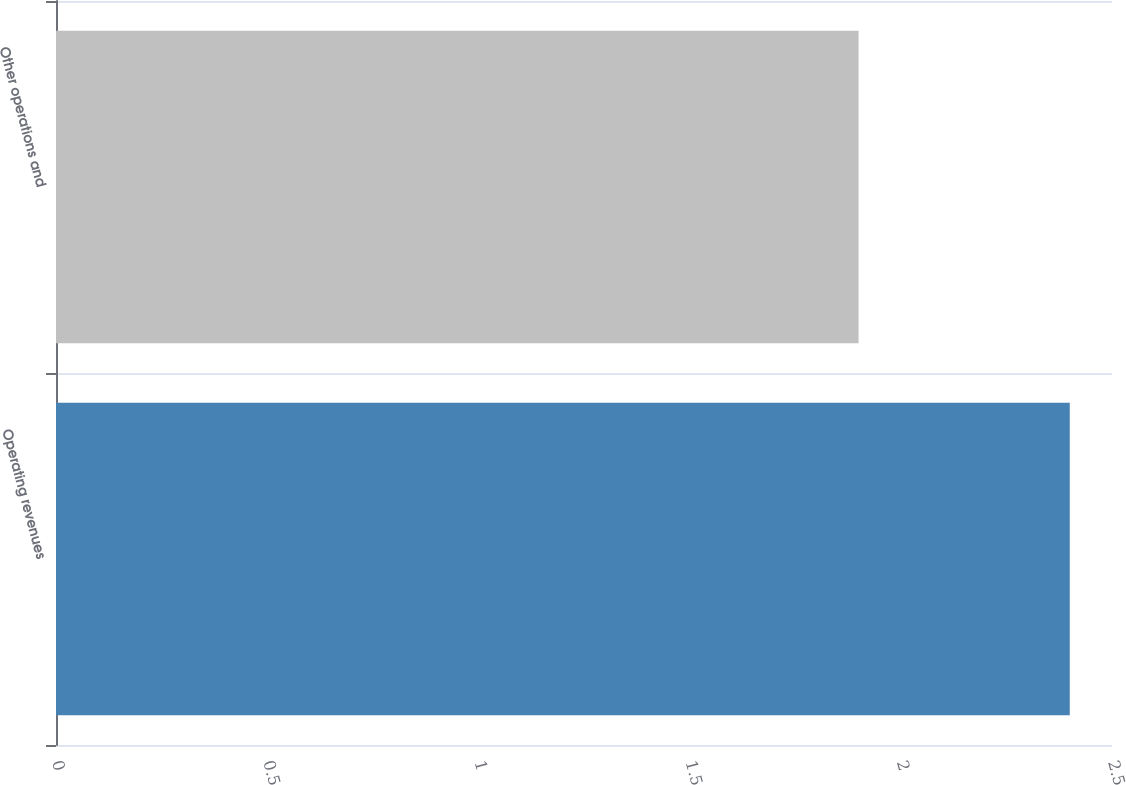<chart> <loc_0><loc_0><loc_500><loc_500><bar_chart><fcel>Operating revenues<fcel>Other operations and<nl><fcel>2.4<fcel>1.9<nl></chart> 